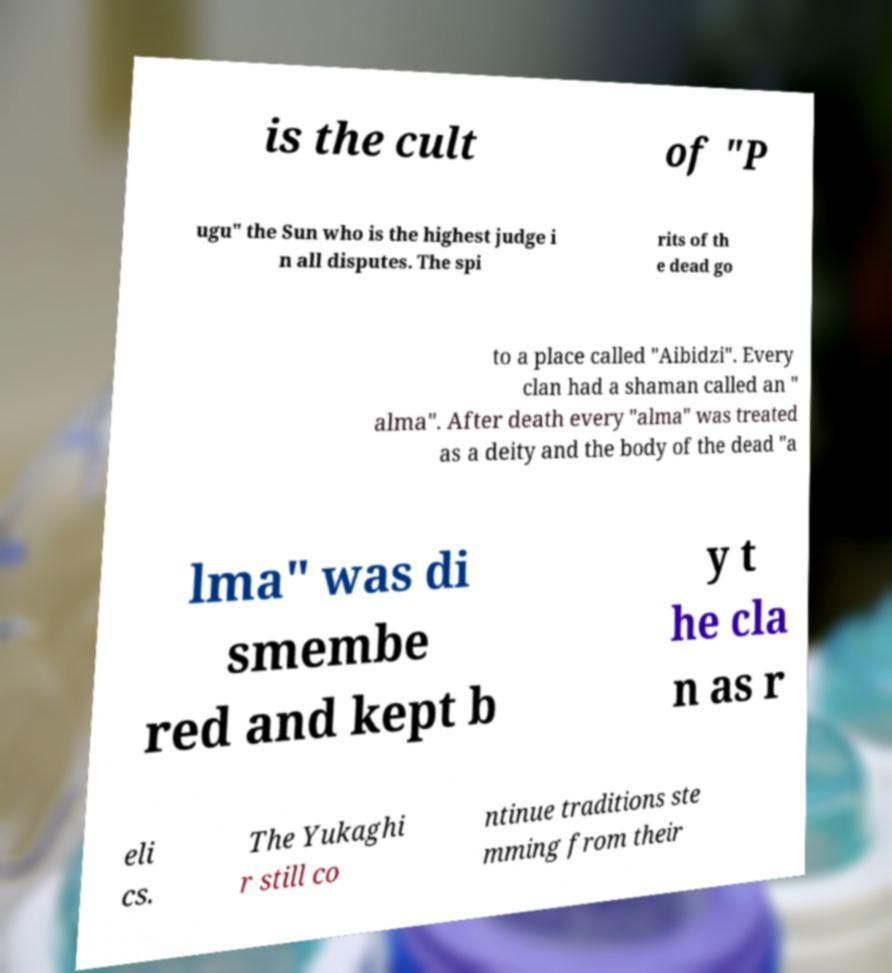Can you accurately transcribe the text from the provided image for me? is the cult of "P ugu" the Sun who is the highest judge i n all disputes. The spi rits of th e dead go to a place called "Aibidzi". Every clan had a shaman called an " alma". After death every "alma" was treated as a deity and the body of the dead "a lma" was di smembe red and kept b y t he cla n as r eli cs. The Yukaghi r still co ntinue traditions ste mming from their 